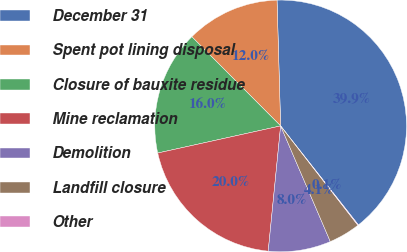<chart> <loc_0><loc_0><loc_500><loc_500><pie_chart><fcel>December 31<fcel>Spent pot lining disposal<fcel>Closure of bauxite residue<fcel>Mine reclamation<fcel>Demolition<fcel>Landfill closure<fcel>Other<nl><fcel>39.86%<fcel>12.01%<fcel>15.99%<fcel>19.97%<fcel>8.03%<fcel>4.06%<fcel>0.08%<nl></chart> 